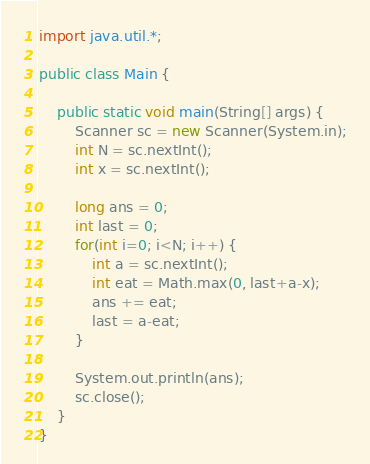<code> <loc_0><loc_0><loc_500><loc_500><_Java_>import java.util.*;

public class Main {

	public static void main(String[] args) {
		Scanner sc = new Scanner(System.in);
		int N = sc.nextInt();
		int x = sc.nextInt();
		
		long ans = 0;
		int last = 0;
		for(int i=0; i<N; i++) {
			int a = sc.nextInt();
			int eat = Math.max(0, last+a-x);
			ans += eat;
			last = a-eat;
		}
		
		System.out.println(ans);
		sc.close();
	}
}
</code> 